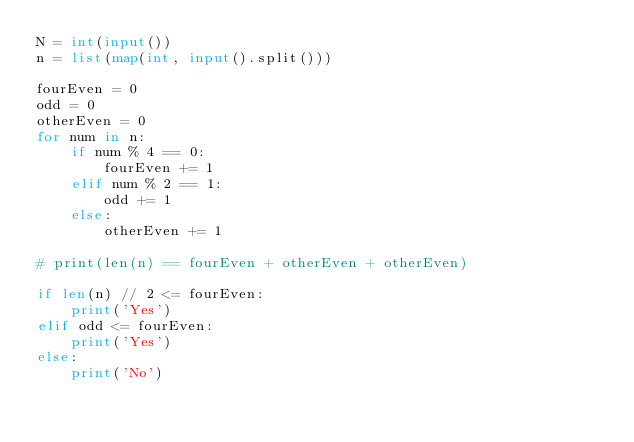Convert code to text. <code><loc_0><loc_0><loc_500><loc_500><_Python_>N = int(input())
n = list(map(int, input().split()))

fourEven = 0
odd = 0
otherEven = 0
for num in n:
    if num % 4 == 0:
        fourEven += 1
    elif num % 2 == 1:
        odd += 1
    else:
        otherEven += 1

# print(len(n) == fourEven + otherEven + otherEven)

if len(n) // 2 <= fourEven:
    print('Yes')
elif odd <= fourEven:
    print('Yes')
else:
    print('No')</code> 